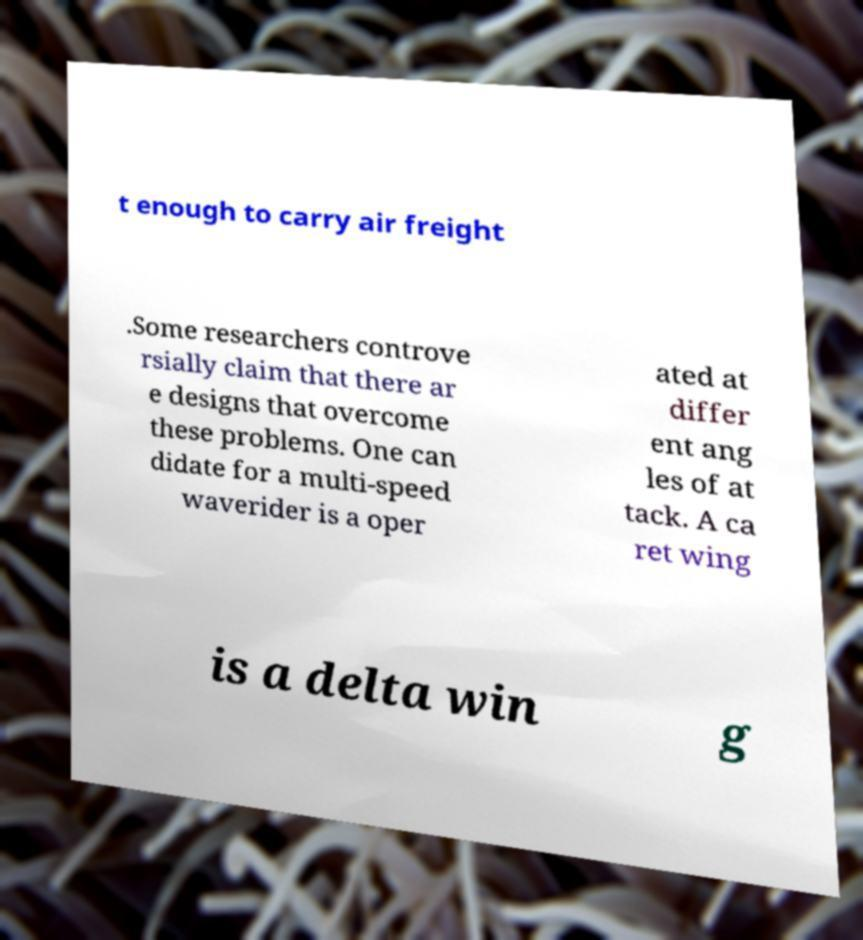Can you accurately transcribe the text from the provided image for me? t enough to carry air freight .Some researchers controve rsially claim that there ar e designs that overcome these problems. One can didate for a multi-speed waverider is a oper ated at differ ent ang les of at tack. A ca ret wing is a delta win g 